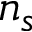<formula> <loc_0><loc_0><loc_500><loc_500>n _ { s }</formula> 